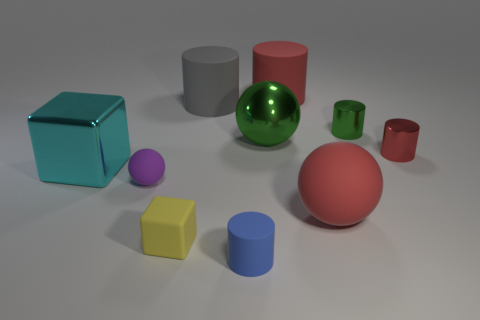There is a matte thing that is in front of the small rubber sphere and to the right of the big green shiny sphere; what size is it?
Offer a terse response. Large. Are there more red things behind the large green shiny ball than large rubber objects?
Provide a short and direct response. No. How many balls are large cyan metallic things or large gray matte objects?
Your answer should be compact. 0. There is a red thing that is both left of the red shiny thing and behind the big matte ball; what is its shape?
Your answer should be very brief. Cylinder. Are there the same number of shiny things that are behind the large green ball and small blue things behind the yellow thing?
Your response must be concise. No. What number of objects are small brown cylinders or shiny objects?
Give a very brief answer. 4. What is the color of the matte cylinder that is the same size as the purple rubber object?
Provide a succinct answer. Blue. What number of things are either big cylinders that are behind the gray matte object or balls that are left of the red matte cylinder?
Offer a terse response. 3. Are there the same number of large cyan metallic objects that are to the right of the big gray rubber cylinder and tiny balls?
Give a very brief answer. No. There is a matte cylinder on the right side of the blue object; is its size the same as the sphere behind the purple matte thing?
Ensure brevity in your answer.  Yes. 